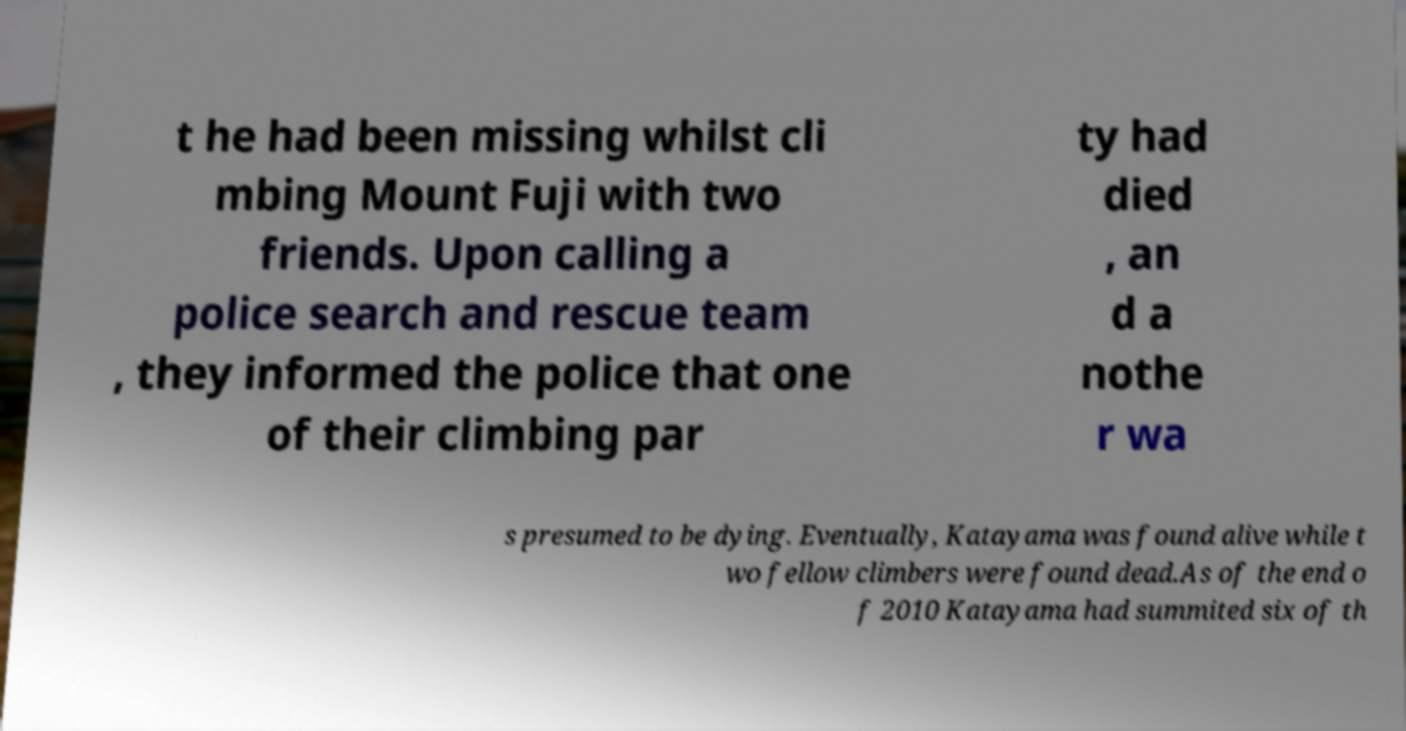Could you assist in decoding the text presented in this image and type it out clearly? t he had been missing whilst cli mbing Mount Fuji with two friends. Upon calling a police search and rescue team , they informed the police that one of their climbing par ty had died , an d a nothe r wa s presumed to be dying. Eventually, Katayama was found alive while t wo fellow climbers were found dead.As of the end o f 2010 Katayama had summited six of th 